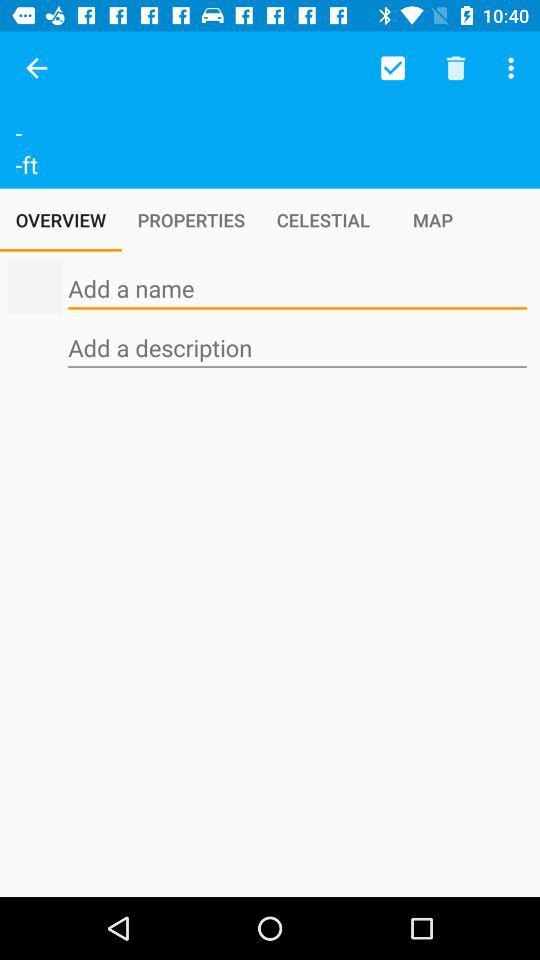Which tab is selected? The selected tab is "OVERVIEW". 